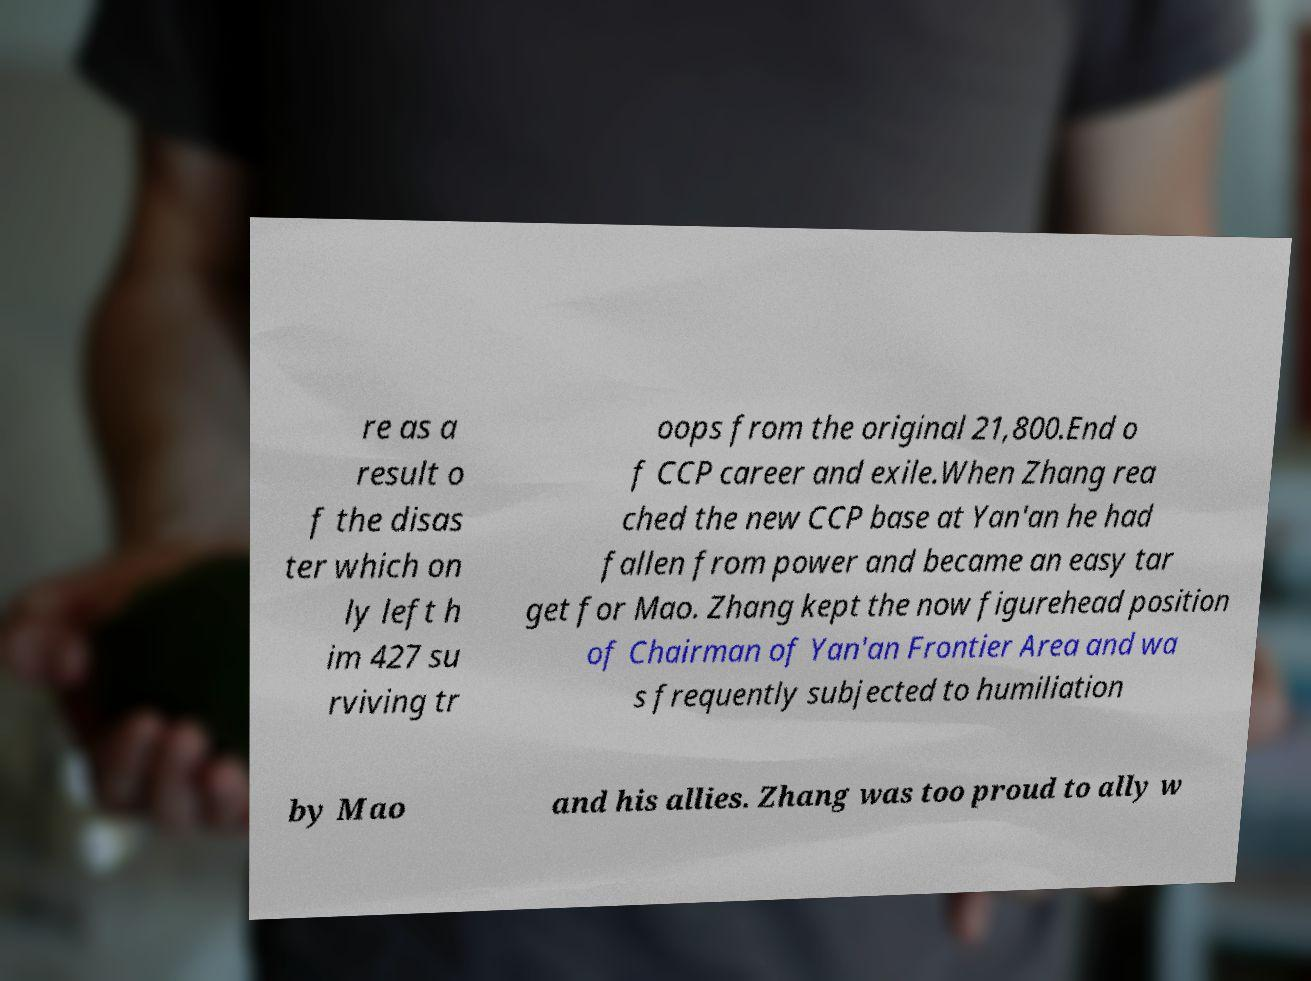What messages or text are displayed in this image? I need them in a readable, typed format. re as a result o f the disas ter which on ly left h im 427 su rviving tr oops from the original 21,800.End o f CCP career and exile.When Zhang rea ched the new CCP base at Yan'an he had fallen from power and became an easy tar get for Mao. Zhang kept the now figurehead position of Chairman of Yan'an Frontier Area and wa s frequently subjected to humiliation by Mao and his allies. Zhang was too proud to ally w 